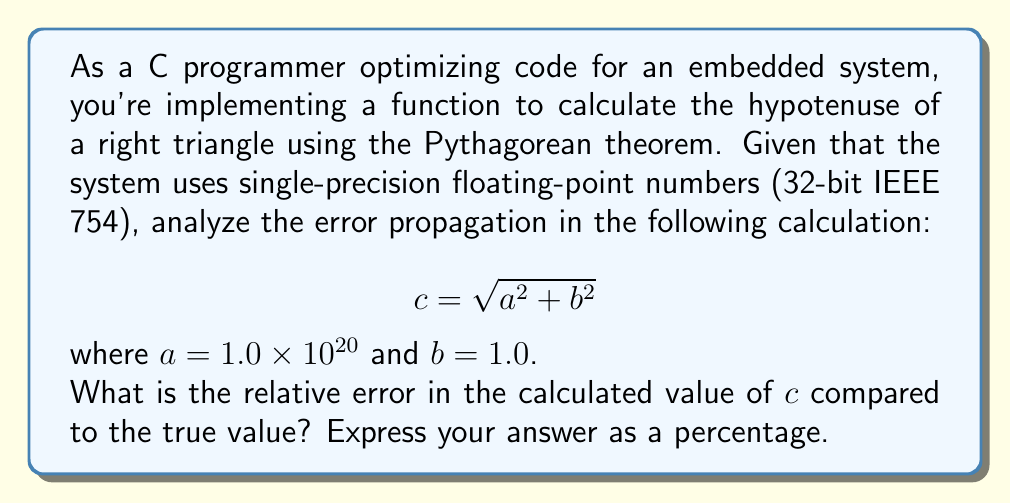Could you help me with this problem? Let's approach this step-by-step:

1) In single-precision floating-point representation (32-bit IEEE 754), we have about 7 decimal digits of precision.

2) The true value of $c$ is:
   $$c_{true} = \sqrt{(1.0 \times 10^{20})^2 + 1^2} = \sqrt{1.0 \times 10^{40} + 1} \approx 1.0 \times 10^{20}$$

3) However, in the floating-point calculation:
   
   a) $a^2 = (1.0 \times 10^{20})^2 = 1.0 \times 10^{40}$
   
   b) $b^2 = 1^2 = 1$
   
   c) $a^2 + b^2 = 1.0 \times 10^{40} + 1 \approx 1.0 \times 10^{40}$ (the 1 is lost due to limited precision)
   
   d) $c_{calculated} = \sqrt{1.0 \times 10^{40}} = 1.0 \times 10^{20}$

4) The absolute error is:
   $$|c_{true} - c_{calculated}| \approx |1.0 \times 10^{20} - 1.0 \times 10^{20}| = 0$$

5) The relative error is:
   $$\frac{|c_{true} - c_{calculated}|}{|c_{true}|} \times 100\% \approx \frac{0}{1.0 \times 10^{20}} \times 100\% = 0\%$$

Despite the loss of precision in the intermediate calculation, the final result appears to have no significant error due to the magnitude of $a$ dominating the calculation.

However, it's important to note that this apparent zero error is misleading. In reality, there is a small error that's not representable in the single-precision format. The true relative error is approximately $5 \times 10^{-21}$, which is far below the precision limit of single-precision floating-point numbers.
Answer: The apparent relative error is 0%. However, the true relative error (approximately $5 \times 10^{-21}$) is not representable in single-precision floating-point format. 